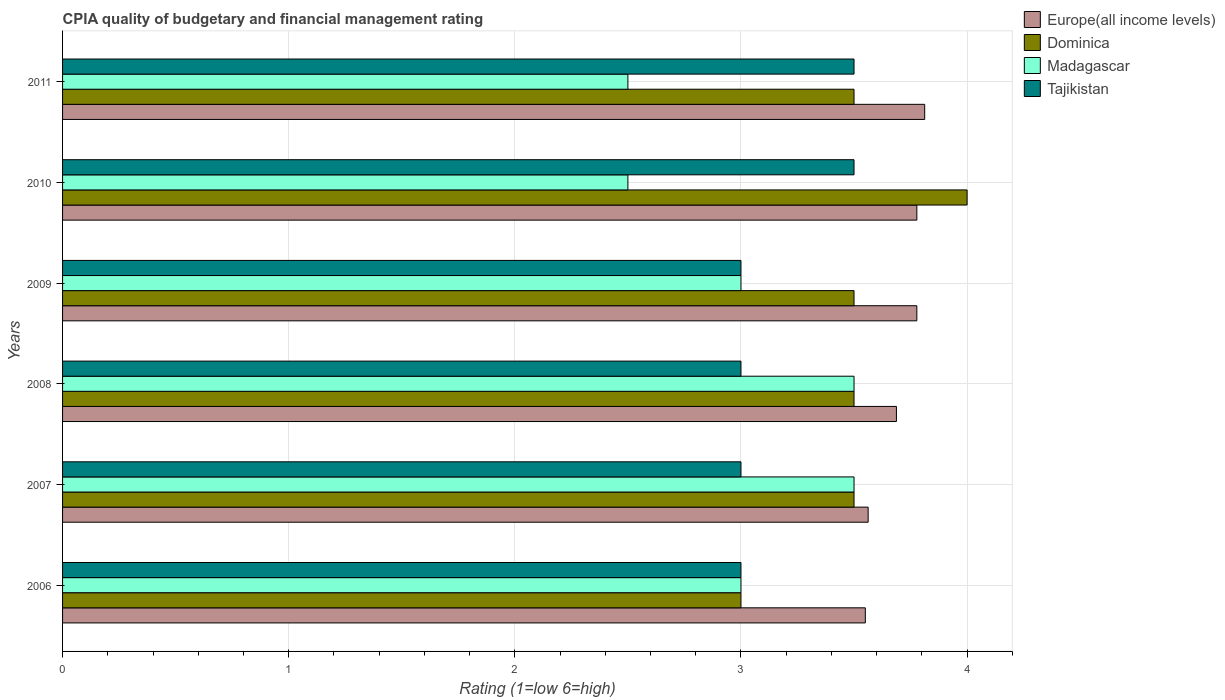How many different coloured bars are there?
Keep it short and to the point. 4. Are the number of bars on each tick of the Y-axis equal?
Offer a terse response. Yes. How many bars are there on the 6th tick from the top?
Offer a terse response. 4. How many bars are there on the 4th tick from the bottom?
Offer a very short reply. 4. What is the CPIA rating in Tajikistan in 2010?
Offer a very short reply. 3.5. Across all years, what is the minimum CPIA rating in Europe(all income levels)?
Your answer should be compact. 3.55. In which year was the CPIA rating in Dominica maximum?
Provide a short and direct response. 2010. In which year was the CPIA rating in Europe(all income levels) minimum?
Your response must be concise. 2006. What is the total CPIA rating in Dominica in the graph?
Ensure brevity in your answer.  21. What is the difference between the CPIA rating in Madagascar in 2008 and the CPIA rating in Europe(all income levels) in 2007?
Your answer should be very brief. -0.06. What is the average CPIA rating in Tajikistan per year?
Ensure brevity in your answer.  3.17. Is the CPIA rating in Tajikistan in 2007 less than that in 2008?
Keep it short and to the point. No. Is the difference between the CPIA rating in Tajikistan in 2008 and 2009 greater than the difference between the CPIA rating in Dominica in 2008 and 2009?
Offer a very short reply. No. What is the difference between the highest and the second highest CPIA rating in Dominica?
Your answer should be compact. 0.5. What is the difference between the highest and the lowest CPIA rating in Europe(all income levels)?
Offer a terse response. 0.26. Is the sum of the CPIA rating in Europe(all income levels) in 2007 and 2008 greater than the maximum CPIA rating in Dominica across all years?
Provide a short and direct response. Yes. Is it the case that in every year, the sum of the CPIA rating in Tajikistan and CPIA rating in Dominica is greater than the sum of CPIA rating in Europe(all income levels) and CPIA rating in Madagascar?
Give a very brief answer. No. What does the 4th bar from the top in 2007 represents?
Your answer should be compact. Europe(all income levels). What does the 2nd bar from the bottom in 2008 represents?
Give a very brief answer. Dominica. Is it the case that in every year, the sum of the CPIA rating in Tajikistan and CPIA rating in Madagascar is greater than the CPIA rating in Dominica?
Offer a terse response. Yes. How many years are there in the graph?
Ensure brevity in your answer.  6. Does the graph contain any zero values?
Make the answer very short. No. How are the legend labels stacked?
Offer a very short reply. Vertical. What is the title of the graph?
Your response must be concise. CPIA quality of budgetary and financial management rating. Does "Azerbaijan" appear as one of the legend labels in the graph?
Your answer should be compact. No. What is the label or title of the X-axis?
Ensure brevity in your answer.  Rating (1=low 6=high). What is the Rating (1=low 6=high) in Europe(all income levels) in 2006?
Keep it short and to the point. 3.55. What is the Rating (1=low 6=high) in Tajikistan in 2006?
Offer a terse response. 3. What is the Rating (1=low 6=high) in Europe(all income levels) in 2007?
Provide a short and direct response. 3.56. What is the Rating (1=low 6=high) in Madagascar in 2007?
Keep it short and to the point. 3.5. What is the Rating (1=low 6=high) of Europe(all income levels) in 2008?
Ensure brevity in your answer.  3.69. What is the Rating (1=low 6=high) of Dominica in 2008?
Provide a succinct answer. 3.5. What is the Rating (1=low 6=high) of Europe(all income levels) in 2009?
Keep it short and to the point. 3.78. What is the Rating (1=low 6=high) in Europe(all income levels) in 2010?
Provide a short and direct response. 3.78. What is the Rating (1=low 6=high) of Tajikistan in 2010?
Your answer should be very brief. 3.5. What is the Rating (1=low 6=high) in Europe(all income levels) in 2011?
Your answer should be very brief. 3.81. What is the Rating (1=low 6=high) of Madagascar in 2011?
Ensure brevity in your answer.  2.5. What is the Rating (1=low 6=high) of Tajikistan in 2011?
Provide a succinct answer. 3.5. Across all years, what is the maximum Rating (1=low 6=high) in Europe(all income levels)?
Your answer should be compact. 3.81. Across all years, what is the maximum Rating (1=low 6=high) of Tajikistan?
Your answer should be compact. 3.5. Across all years, what is the minimum Rating (1=low 6=high) of Europe(all income levels)?
Provide a short and direct response. 3.55. What is the total Rating (1=low 6=high) in Europe(all income levels) in the graph?
Offer a very short reply. 22.17. What is the total Rating (1=low 6=high) in Madagascar in the graph?
Your response must be concise. 18. What is the difference between the Rating (1=low 6=high) of Europe(all income levels) in 2006 and that in 2007?
Offer a terse response. -0.01. What is the difference between the Rating (1=low 6=high) in Madagascar in 2006 and that in 2007?
Make the answer very short. -0.5. What is the difference between the Rating (1=low 6=high) in Europe(all income levels) in 2006 and that in 2008?
Ensure brevity in your answer.  -0.14. What is the difference between the Rating (1=low 6=high) of Madagascar in 2006 and that in 2008?
Offer a terse response. -0.5. What is the difference between the Rating (1=low 6=high) of Tajikistan in 2006 and that in 2008?
Give a very brief answer. 0. What is the difference between the Rating (1=low 6=high) in Europe(all income levels) in 2006 and that in 2009?
Offer a terse response. -0.23. What is the difference between the Rating (1=low 6=high) of Dominica in 2006 and that in 2009?
Provide a short and direct response. -0.5. What is the difference between the Rating (1=low 6=high) in Europe(all income levels) in 2006 and that in 2010?
Provide a short and direct response. -0.23. What is the difference between the Rating (1=low 6=high) in Dominica in 2006 and that in 2010?
Keep it short and to the point. -1. What is the difference between the Rating (1=low 6=high) in Madagascar in 2006 and that in 2010?
Your response must be concise. 0.5. What is the difference between the Rating (1=low 6=high) in Europe(all income levels) in 2006 and that in 2011?
Make the answer very short. -0.26. What is the difference between the Rating (1=low 6=high) in Dominica in 2006 and that in 2011?
Your answer should be very brief. -0.5. What is the difference between the Rating (1=low 6=high) of Europe(all income levels) in 2007 and that in 2008?
Make the answer very short. -0.12. What is the difference between the Rating (1=low 6=high) in Madagascar in 2007 and that in 2008?
Offer a terse response. 0. What is the difference between the Rating (1=low 6=high) in Tajikistan in 2007 and that in 2008?
Provide a short and direct response. 0. What is the difference between the Rating (1=low 6=high) in Europe(all income levels) in 2007 and that in 2009?
Offer a very short reply. -0.22. What is the difference between the Rating (1=low 6=high) of Dominica in 2007 and that in 2009?
Provide a short and direct response. 0. What is the difference between the Rating (1=low 6=high) in Europe(all income levels) in 2007 and that in 2010?
Provide a succinct answer. -0.22. What is the difference between the Rating (1=low 6=high) of Dominica in 2007 and that in 2010?
Provide a succinct answer. -0.5. What is the difference between the Rating (1=low 6=high) of Madagascar in 2007 and that in 2010?
Your answer should be compact. 1. What is the difference between the Rating (1=low 6=high) in Tajikistan in 2007 and that in 2010?
Give a very brief answer. -0.5. What is the difference between the Rating (1=low 6=high) of Dominica in 2007 and that in 2011?
Offer a terse response. 0. What is the difference between the Rating (1=low 6=high) in Europe(all income levels) in 2008 and that in 2009?
Offer a terse response. -0.09. What is the difference between the Rating (1=low 6=high) of Madagascar in 2008 and that in 2009?
Your answer should be very brief. 0.5. What is the difference between the Rating (1=low 6=high) of Europe(all income levels) in 2008 and that in 2010?
Your response must be concise. -0.09. What is the difference between the Rating (1=low 6=high) in Europe(all income levels) in 2008 and that in 2011?
Your answer should be compact. -0.12. What is the difference between the Rating (1=low 6=high) in Tajikistan in 2008 and that in 2011?
Your answer should be compact. -0.5. What is the difference between the Rating (1=low 6=high) in Europe(all income levels) in 2009 and that in 2010?
Your answer should be compact. 0. What is the difference between the Rating (1=low 6=high) of Dominica in 2009 and that in 2010?
Your answer should be very brief. -0.5. What is the difference between the Rating (1=low 6=high) of Madagascar in 2009 and that in 2010?
Offer a very short reply. 0.5. What is the difference between the Rating (1=low 6=high) of Europe(all income levels) in 2009 and that in 2011?
Offer a terse response. -0.03. What is the difference between the Rating (1=low 6=high) of Madagascar in 2009 and that in 2011?
Make the answer very short. 0.5. What is the difference between the Rating (1=low 6=high) in Europe(all income levels) in 2010 and that in 2011?
Your response must be concise. -0.03. What is the difference between the Rating (1=low 6=high) of Europe(all income levels) in 2006 and the Rating (1=low 6=high) of Dominica in 2007?
Your response must be concise. 0.05. What is the difference between the Rating (1=low 6=high) in Europe(all income levels) in 2006 and the Rating (1=low 6=high) in Tajikistan in 2007?
Offer a very short reply. 0.55. What is the difference between the Rating (1=low 6=high) of Dominica in 2006 and the Rating (1=low 6=high) of Madagascar in 2007?
Offer a very short reply. -0.5. What is the difference between the Rating (1=low 6=high) in Dominica in 2006 and the Rating (1=low 6=high) in Tajikistan in 2007?
Offer a very short reply. 0. What is the difference between the Rating (1=low 6=high) in Madagascar in 2006 and the Rating (1=low 6=high) in Tajikistan in 2007?
Offer a very short reply. 0. What is the difference between the Rating (1=low 6=high) of Europe(all income levels) in 2006 and the Rating (1=low 6=high) of Madagascar in 2008?
Keep it short and to the point. 0.05. What is the difference between the Rating (1=low 6=high) of Europe(all income levels) in 2006 and the Rating (1=low 6=high) of Tajikistan in 2008?
Make the answer very short. 0.55. What is the difference between the Rating (1=low 6=high) of Dominica in 2006 and the Rating (1=low 6=high) of Tajikistan in 2008?
Make the answer very short. 0. What is the difference between the Rating (1=low 6=high) of Europe(all income levels) in 2006 and the Rating (1=low 6=high) of Madagascar in 2009?
Your answer should be compact. 0.55. What is the difference between the Rating (1=low 6=high) of Europe(all income levels) in 2006 and the Rating (1=low 6=high) of Tajikistan in 2009?
Ensure brevity in your answer.  0.55. What is the difference between the Rating (1=low 6=high) in Madagascar in 2006 and the Rating (1=low 6=high) in Tajikistan in 2009?
Your answer should be compact. 0. What is the difference between the Rating (1=low 6=high) in Europe(all income levels) in 2006 and the Rating (1=low 6=high) in Dominica in 2010?
Provide a short and direct response. -0.45. What is the difference between the Rating (1=low 6=high) of Dominica in 2006 and the Rating (1=low 6=high) of Madagascar in 2010?
Ensure brevity in your answer.  0.5. What is the difference between the Rating (1=low 6=high) of Dominica in 2006 and the Rating (1=low 6=high) of Madagascar in 2011?
Your answer should be very brief. 0.5. What is the difference between the Rating (1=low 6=high) of Madagascar in 2006 and the Rating (1=low 6=high) of Tajikistan in 2011?
Keep it short and to the point. -0.5. What is the difference between the Rating (1=low 6=high) of Europe(all income levels) in 2007 and the Rating (1=low 6=high) of Dominica in 2008?
Your answer should be compact. 0.06. What is the difference between the Rating (1=low 6=high) in Europe(all income levels) in 2007 and the Rating (1=low 6=high) in Madagascar in 2008?
Your response must be concise. 0.06. What is the difference between the Rating (1=low 6=high) of Europe(all income levels) in 2007 and the Rating (1=low 6=high) of Tajikistan in 2008?
Give a very brief answer. 0.56. What is the difference between the Rating (1=low 6=high) in Dominica in 2007 and the Rating (1=low 6=high) in Madagascar in 2008?
Provide a succinct answer. 0. What is the difference between the Rating (1=low 6=high) in Dominica in 2007 and the Rating (1=low 6=high) in Tajikistan in 2008?
Provide a short and direct response. 0.5. What is the difference between the Rating (1=low 6=high) of Madagascar in 2007 and the Rating (1=low 6=high) of Tajikistan in 2008?
Your response must be concise. 0.5. What is the difference between the Rating (1=low 6=high) in Europe(all income levels) in 2007 and the Rating (1=low 6=high) in Dominica in 2009?
Offer a terse response. 0.06. What is the difference between the Rating (1=low 6=high) in Europe(all income levels) in 2007 and the Rating (1=low 6=high) in Madagascar in 2009?
Your answer should be compact. 0.56. What is the difference between the Rating (1=low 6=high) in Europe(all income levels) in 2007 and the Rating (1=low 6=high) in Tajikistan in 2009?
Ensure brevity in your answer.  0.56. What is the difference between the Rating (1=low 6=high) of Madagascar in 2007 and the Rating (1=low 6=high) of Tajikistan in 2009?
Make the answer very short. 0.5. What is the difference between the Rating (1=low 6=high) of Europe(all income levels) in 2007 and the Rating (1=low 6=high) of Dominica in 2010?
Your answer should be compact. -0.44. What is the difference between the Rating (1=low 6=high) of Europe(all income levels) in 2007 and the Rating (1=low 6=high) of Madagascar in 2010?
Provide a succinct answer. 1.06. What is the difference between the Rating (1=low 6=high) in Europe(all income levels) in 2007 and the Rating (1=low 6=high) in Tajikistan in 2010?
Provide a succinct answer. 0.06. What is the difference between the Rating (1=low 6=high) of Europe(all income levels) in 2007 and the Rating (1=low 6=high) of Dominica in 2011?
Offer a terse response. 0.06. What is the difference between the Rating (1=low 6=high) of Europe(all income levels) in 2007 and the Rating (1=low 6=high) of Madagascar in 2011?
Provide a short and direct response. 1.06. What is the difference between the Rating (1=low 6=high) in Europe(all income levels) in 2007 and the Rating (1=low 6=high) in Tajikistan in 2011?
Offer a terse response. 0.06. What is the difference between the Rating (1=low 6=high) in Europe(all income levels) in 2008 and the Rating (1=low 6=high) in Dominica in 2009?
Your response must be concise. 0.19. What is the difference between the Rating (1=low 6=high) of Europe(all income levels) in 2008 and the Rating (1=low 6=high) of Madagascar in 2009?
Ensure brevity in your answer.  0.69. What is the difference between the Rating (1=low 6=high) of Europe(all income levels) in 2008 and the Rating (1=low 6=high) of Tajikistan in 2009?
Your response must be concise. 0.69. What is the difference between the Rating (1=low 6=high) in Dominica in 2008 and the Rating (1=low 6=high) in Madagascar in 2009?
Your answer should be compact. 0.5. What is the difference between the Rating (1=low 6=high) in Madagascar in 2008 and the Rating (1=low 6=high) in Tajikistan in 2009?
Your response must be concise. 0.5. What is the difference between the Rating (1=low 6=high) in Europe(all income levels) in 2008 and the Rating (1=low 6=high) in Dominica in 2010?
Give a very brief answer. -0.31. What is the difference between the Rating (1=low 6=high) of Europe(all income levels) in 2008 and the Rating (1=low 6=high) of Madagascar in 2010?
Your answer should be very brief. 1.19. What is the difference between the Rating (1=low 6=high) in Europe(all income levels) in 2008 and the Rating (1=low 6=high) in Tajikistan in 2010?
Provide a short and direct response. 0.19. What is the difference between the Rating (1=low 6=high) in Dominica in 2008 and the Rating (1=low 6=high) in Madagascar in 2010?
Your response must be concise. 1. What is the difference between the Rating (1=low 6=high) of Dominica in 2008 and the Rating (1=low 6=high) of Tajikistan in 2010?
Offer a very short reply. 0. What is the difference between the Rating (1=low 6=high) of Madagascar in 2008 and the Rating (1=low 6=high) of Tajikistan in 2010?
Your answer should be compact. 0. What is the difference between the Rating (1=low 6=high) in Europe(all income levels) in 2008 and the Rating (1=low 6=high) in Dominica in 2011?
Offer a very short reply. 0.19. What is the difference between the Rating (1=low 6=high) in Europe(all income levels) in 2008 and the Rating (1=low 6=high) in Madagascar in 2011?
Keep it short and to the point. 1.19. What is the difference between the Rating (1=low 6=high) in Europe(all income levels) in 2008 and the Rating (1=low 6=high) in Tajikistan in 2011?
Offer a very short reply. 0.19. What is the difference between the Rating (1=low 6=high) in Dominica in 2008 and the Rating (1=low 6=high) in Tajikistan in 2011?
Provide a succinct answer. 0. What is the difference between the Rating (1=low 6=high) of Madagascar in 2008 and the Rating (1=low 6=high) of Tajikistan in 2011?
Offer a very short reply. 0. What is the difference between the Rating (1=low 6=high) in Europe(all income levels) in 2009 and the Rating (1=low 6=high) in Dominica in 2010?
Provide a short and direct response. -0.22. What is the difference between the Rating (1=low 6=high) in Europe(all income levels) in 2009 and the Rating (1=low 6=high) in Madagascar in 2010?
Offer a terse response. 1.28. What is the difference between the Rating (1=low 6=high) of Europe(all income levels) in 2009 and the Rating (1=low 6=high) of Tajikistan in 2010?
Give a very brief answer. 0.28. What is the difference between the Rating (1=low 6=high) in Dominica in 2009 and the Rating (1=low 6=high) in Madagascar in 2010?
Your response must be concise. 1. What is the difference between the Rating (1=low 6=high) in Madagascar in 2009 and the Rating (1=low 6=high) in Tajikistan in 2010?
Your response must be concise. -0.5. What is the difference between the Rating (1=low 6=high) in Europe(all income levels) in 2009 and the Rating (1=low 6=high) in Dominica in 2011?
Your response must be concise. 0.28. What is the difference between the Rating (1=low 6=high) in Europe(all income levels) in 2009 and the Rating (1=low 6=high) in Madagascar in 2011?
Make the answer very short. 1.28. What is the difference between the Rating (1=low 6=high) of Europe(all income levels) in 2009 and the Rating (1=low 6=high) of Tajikistan in 2011?
Provide a succinct answer. 0.28. What is the difference between the Rating (1=low 6=high) in Dominica in 2009 and the Rating (1=low 6=high) in Madagascar in 2011?
Give a very brief answer. 1. What is the difference between the Rating (1=low 6=high) in Dominica in 2009 and the Rating (1=low 6=high) in Tajikistan in 2011?
Make the answer very short. 0. What is the difference between the Rating (1=low 6=high) of Europe(all income levels) in 2010 and the Rating (1=low 6=high) of Dominica in 2011?
Ensure brevity in your answer.  0.28. What is the difference between the Rating (1=low 6=high) in Europe(all income levels) in 2010 and the Rating (1=low 6=high) in Madagascar in 2011?
Provide a short and direct response. 1.28. What is the difference between the Rating (1=low 6=high) in Europe(all income levels) in 2010 and the Rating (1=low 6=high) in Tajikistan in 2011?
Give a very brief answer. 0.28. What is the average Rating (1=low 6=high) of Europe(all income levels) per year?
Offer a very short reply. 3.69. What is the average Rating (1=low 6=high) of Dominica per year?
Keep it short and to the point. 3.5. What is the average Rating (1=low 6=high) in Tajikistan per year?
Provide a short and direct response. 3.17. In the year 2006, what is the difference between the Rating (1=low 6=high) in Europe(all income levels) and Rating (1=low 6=high) in Dominica?
Keep it short and to the point. 0.55. In the year 2006, what is the difference between the Rating (1=low 6=high) of Europe(all income levels) and Rating (1=low 6=high) of Madagascar?
Ensure brevity in your answer.  0.55. In the year 2006, what is the difference between the Rating (1=low 6=high) of Europe(all income levels) and Rating (1=low 6=high) of Tajikistan?
Provide a succinct answer. 0.55. In the year 2006, what is the difference between the Rating (1=low 6=high) in Dominica and Rating (1=low 6=high) in Madagascar?
Offer a terse response. 0. In the year 2006, what is the difference between the Rating (1=low 6=high) of Madagascar and Rating (1=low 6=high) of Tajikistan?
Give a very brief answer. 0. In the year 2007, what is the difference between the Rating (1=low 6=high) in Europe(all income levels) and Rating (1=low 6=high) in Dominica?
Your answer should be compact. 0.06. In the year 2007, what is the difference between the Rating (1=low 6=high) in Europe(all income levels) and Rating (1=low 6=high) in Madagascar?
Ensure brevity in your answer.  0.06. In the year 2007, what is the difference between the Rating (1=low 6=high) of Europe(all income levels) and Rating (1=low 6=high) of Tajikistan?
Offer a terse response. 0.56. In the year 2007, what is the difference between the Rating (1=low 6=high) in Dominica and Rating (1=low 6=high) in Madagascar?
Offer a terse response. 0. In the year 2007, what is the difference between the Rating (1=low 6=high) in Dominica and Rating (1=low 6=high) in Tajikistan?
Your answer should be very brief. 0.5. In the year 2008, what is the difference between the Rating (1=low 6=high) of Europe(all income levels) and Rating (1=low 6=high) of Dominica?
Offer a terse response. 0.19. In the year 2008, what is the difference between the Rating (1=low 6=high) in Europe(all income levels) and Rating (1=low 6=high) in Madagascar?
Provide a short and direct response. 0.19. In the year 2008, what is the difference between the Rating (1=low 6=high) in Europe(all income levels) and Rating (1=low 6=high) in Tajikistan?
Offer a very short reply. 0.69. In the year 2008, what is the difference between the Rating (1=low 6=high) in Dominica and Rating (1=low 6=high) in Madagascar?
Your answer should be compact. 0. In the year 2008, what is the difference between the Rating (1=low 6=high) in Dominica and Rating (1=low 6=high) in Tajikistan?
Your response must be concise. 0.5. In the year 2008, what is the difference between the Rating (1=low 6=high) of Madagascar and Rating (1=low 6=high) of Tajikistan?
Make the answer very short. 0.5. In the year 2009, what is the difference between the Rating (1=low 6=high) of Europe(all income levels) and Rating (1=low 6=high) of Dominica?
Provide a succinct answer. 0.28. In the year 2009, what is the difference between the Rating (1=low 6=high) of Europe(all income levels) and Rating (1=low 6=high) of Madagascar?
Provide a succinct answer. 0.78. In the year 2009, what is the difference between the Rating (1=low 6=high) of Madagascar and Rating (1=low 6=high) of Tajikistan?
Your answer should be very brief. 0. In the year 2010, what is the difference between the Rating (1=low 6=high) in Europe(all income levels) and Rating (1=low 6=high) in Dominica?
Provide a short and direct response. -0.22. In the year 2010, what is the difference between the Rating (1=low 6=high) in Europe(all income levels) and Rating (1=low 6=high) in Madagascar?
Your answer should be compact. 1.28. In the year 2010, what is the difference between the Rating (1=low 6=high) in Europe(all income levels) and Rating (1=low 6=high) in Tajikistan?
Offer a very short reply. 0.28. In the year 2010, what is the difference between the Rating (1=low 6=high) in Dominica and Rating (1=low 6=high) in Madagascar?
Ensure brevity in your answer.  1.5. In the year 2010, what is the difference between the Rating (1=low 6=high) in Dominica and Rating (1=low 6=high) in Tajikistan?
Ensure brevity in your answer.  0.5. In the year 2011, what is the difference between the Rating (1=low 6=high) of Europe(all income levels) and Rating (1=low 6=high) of Dominica?
Provide a short and direct response. 0.31. In the year 2011, what is the difference between the Rating (1=low 6=high) in Europe(all income levels) and Rating (1=low 6=high) in Madagascar?
Keep it short and to the point. 1.31. In the year 2011, what is the difference between the Rating (1=low 6=high) in Europe(all income levels) and Rating (1=low 6=high) in Tajikistan?
Offer a terse response. 0.31. In the year 2011, what is the difference between the Rating (1=low 6=high) of Dominica and Rating (1=low 6=high) of Madagascar?
Give a very brief answer. 1. In the year 2011, what is the difference between the Rating (1=low 6=high) of Dominica and Rating (1=low 6=high) of Tajikistan?
Make the answer very short. 0. What is the ratio of the Rating (1=low 6=high) of Dominica in 2006 to that in 2007?
Offer a very short reply. 0.86. What is the ratio of the Rating (1=low 6=high) in Europe(all income levels) in 2006 to that in 2008?
Your answer should be compact. 0.96. What is the ratio of the Rating (1=low 6=high) in Dominica in 2006 to that in 2008?
Keep it short and to the point. 0.86. What is the ratio of the Rating (1=low 6=high) in Madagascar in 2006 to that in 2008?
Provide a short and direct response. 0.86. What is the ratio of the Rating (1=low 6=high) in Tajikistan in 2006 to that in 2008?
Your answer should be very brief. 1. What is the ratio of the Rating (1=low 6=high) of Europe(all income levels) in 2006 to that in 2009?
Offer a terse response. 0.94. What is the ratio of the Rating (1=low 6=high) in Dominica in 2006 to that in 2009?
Provide a short and direct response. 0.86. What is the ratio of the Rating (1=low 6=high) of Madagascar in 2006 to that in 2009?
Keep it short and to the point. 1. What is the ratio of the Rating (1=low 6=high) in Europe(all income levels) in 2006 to that in 2010?
Your answer should be compact. 0.94. What is the ratio of the Rating (1=low 6=high) of Tajikistan in 2006 to that in 2010?
Provide a succinct answer. 0.86. What is the ratio of the Rating (1=low 6=high) of Europe(all income levels) in 2006 to that in 2011?
Offer a terse response. 0.93. What is the ratio of the Rating (1=low 6=high) in Dominica in 2006 to that in 2011?
Give a very brief answer. 0.86. What is the ratio of the Rating (1=low 6=high) in Madagascar in 2006 to that in 2011?
Provide a succinct answer. 1.2. What is the ratio of the Rating (1=low 6=high) of Tajikistan in 2006 to that in 2011?
Provide a succinct answer. 0.86. What is the ratio of the Rating (1=low 6=high) of Europe(all income levels) in 2007 to that in 2008?
Keep it short and to the point. 0.97. What is the ratio of the Rating (1=low 6=high) in Madagascar in 2007 to that in 2008?
Offer a terse response. 1. What is the ratio of the Rating (1=low 6=high) of Tajikistan in 2007 to that in 2008?
Your answer should be compact. 1. What is the ratio of the Rating (1=low 6=high) in Europe(all income levels) in 2007 to that in 2009?
Your response must be concise. 0.94. What is the ratio of the Rating (1=low 6=high) in Dominica in 2007 to that in 2009?
Give a very brief answer. 1. What is the ratio of the Rating (1=low 6=high) of Tajikistan in 2007 to that in 2009?
Offer a very short reply. 1. What is the ratio of the Rating (1=low 6=high) in Europe(all income levels) in 2007 to that in 2010?
Offer a terse response. 0.94. What is the ratio of the Rating (1=low 6=high) of Dominica in 2007 to that in 2010?
Offer a very short reply. 0.88. What is the ratio of the Rating (1=low 6=high) in Europe(all income levels) in 2007 to that in 2011?
Your response must be concise. 0.93. What is the ratio of the Rating (1=low 6=high) of Europe(all income levels) in 2008 to that in 2009?
Your answer should be very brief. 0.98. What is the ratio of the Rating (1=low 6=high) in Madagascar in 2008 to that in 2009?
Provide a short and direct response. 1.17. What is the ratio of the Rating (1=low 6=high) in Europe(all income levels) in 2008 to that in 2010?
Provide a succinct answer. 0.98. What is the ratio of the Rating (1=low 6=high) of Dominica in 2008 to that in 2010?
Your answer should be compact. 0.88. What is the ratio of the Rating (1=low 6=high) in Madagascar in 2008 to that in 2010?
Provide a short and direct response. 1.4. What is the ratio of the Rating (1=low 6=high) of Europe(all income levels) in 2008 to that in 2011?
Give a very brief answer. 0.97. What is the ratio of the Rating (1=low 6=high) of Madagascar in 2008 to that in 2011?
Your answer should be very brief. 1.4. What is the ratio of the Rating (1=low 6=high) of Tajikistan in 2008 to that in 2011?
Your answer should be very brief. 0.86. What is the ratio of the Rating (1=low 6=high) in Europe(all income levels) in 2009 to that in 2010?
Your answer should be very brief. 1. What is the ratio of the Rating (1=low 6=high) in Madagascar in 2009 to that in 2010?
Offer a very short reply. 1.2. What is the ratio of the Rating (1=low 6=high) in Tajikistan in 2009 to that in 2010?
Your answer should be compact. 0.86. What is the ratio of the Rating (1=low 6=high) in Europe(all income levels) in 2009 to that in 2011?
Offer a terse response. 0.99. What is the ratio of the Rating (1=low 6=high) of Europe(all income levels) in 2010 to that in 2011?
Make the answer very short. 0.99. What is the difference between the highest and the second highest Rating (1=low 6=high) of Europe(all income levels)?
Provide a short and direct response. 0.03. What is the difference between the highest and the second highest Rating (1=low 6=high) in Dominica?
Your answer should be very brief. 0.5. What is the difference between the highest and the second highest Rating (1=low 6=high) in Madagascar?
Provide a succinct answer. 0. What is the difference between the highest and the second highest Rating (1=low 6=high) of Tajikistan?
Your response must be concise. 0. What is the difference between the highest and the lowest Rating (1=low 6=high) in Europe(all income levels)?
Offer a very short reply. 0.26. What is the difference between the highest and the lowest Rating (1=low 6=high) in Dominica?
Keep it short and to the point. 1. What is the difference between the highest and the lowest Rating (1=low 6=high) of Madagascar?
Make the answer very short. 1. What is the difference between the highest and the lowest Rating (1=low 6=high) of Tajikistan?
Your response must be concise. 0.5. 